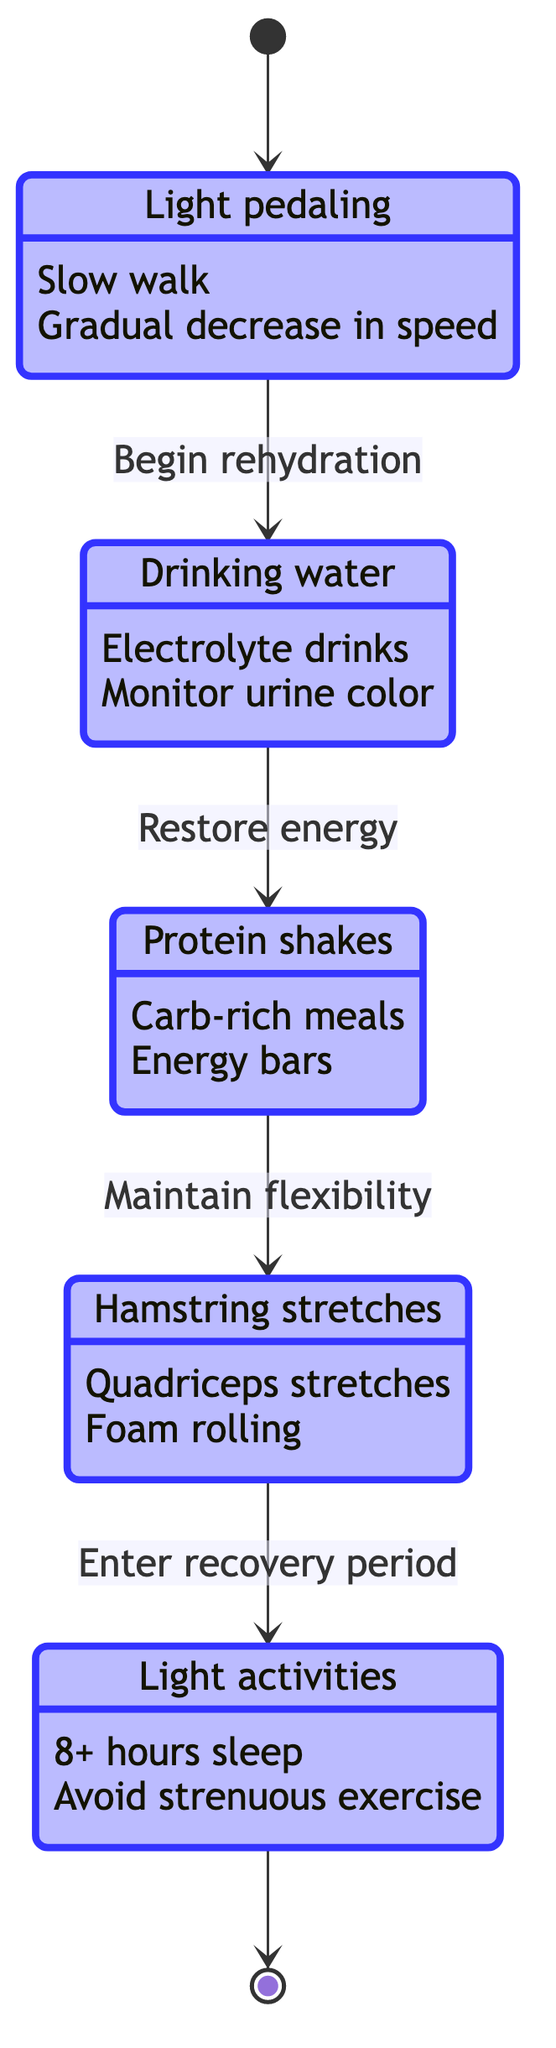What is the first state after the race? The state diagram starts with the arrow pointing from the initial state to the "PostRaceCooldown" state, indicating that this is the first action taken after finishing a race.
Answer: PostRaceCooldown How many states are represented in the diagram? By counting the different states listed in the diagram—PostRaceCooldown, Hydration, NutritionalIntake, Stretching, and RestDays—there are a total of five distinct states.
Answer: 5 What action follows Hydration? The diagram shows that after "Hydration," the next transition leads to the "NutritionalIntake" state, indicating that the next action involves replenishing energy through food intake.
Answer: NutritionalIntake What is the last state in the recovery process? The diagram indicates that the final transition leads to the "[*]" state, which signifies the completion of the recovery process, making RestDays the last active state before returning to the initial state.
Answer: RestDays Which state involves monitoring urine color? In the "Hydration" state, one of the actions listed is "Monitoring urine color for adequate hydration," indicating that this is the relevant action related to that specific state.
Answer: Hydration What is the transition between NutritionalIntake and Stretching? The diagram specifies that the transition from "NutritionalIntake" to "Stretching" is marked with the action "Post-meal, engage in stretching exercises to maintain flexibility and reduce soreness," defining the relationship between these two states.
Answer: Maintain flexibility What is an action you take during PostRaceCooldown? One valid action during the "PostRaceCooldown" state is "Light pedaling," which indicates a mild exercise to help the body cool down after the race.
Answer: Light pedaling What follows after Stretching in the recovery process? The diagram illustrates that after completing stretching exercises, the athlete transitions to "RestDays" for recovery, confirming that rest follows stretching.
Answer: RestDays How does Hydration lead to NutritionalIntake? The transition description states, "Once adequately hydrated, focus shifts to restoring energy through food intake," which explains the flow from Hydration to NutritionalIntake, emphasizing that hydration is a prerequisite for nutritional intake.
Answer: Restore energy 